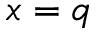Convert formula to latex. <formula><loc_0><loc_0><loc_500><loc_500>x = q</formula> 